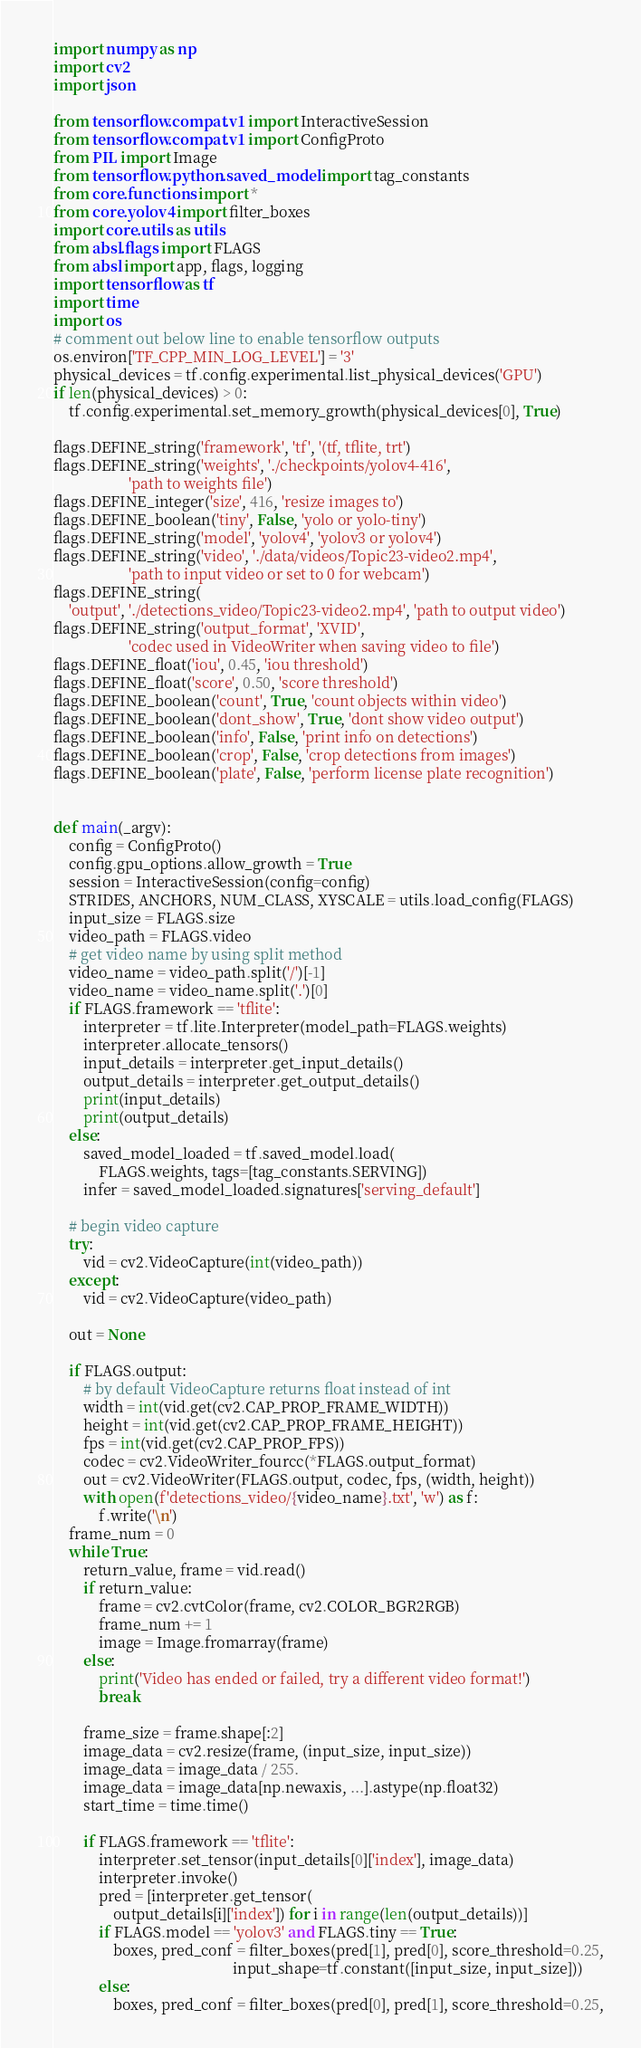<code> <loc_0><loc_0><loc_500><loc_500><_Python_>import numpy as np
import cv2
import json

from tensorflow.compat.v1 import InteractiveSession
from tensorflow.compat.v1 import ConfigProto
from PIL import Image
from tensorflow.python.saved_model import tag_constants
from core.functions import *
from core.yolov4 import filter_boxes
import core.utils as utils
from absl.flags import FLAGS
from absl import app, flags, logging
import tensorflow as tf
import time
import os
# comment out below line to enable tensorflow outputs
os.environ['TF_CPP_MIN_LOG_LEVEL'] = '3'
physical_devices = tf.config.experimental.list_physical_devices('GPU')
if len(physical_devices) > 0:
    tf.config.experimental.set_memory_growth(physical_devices[0], True)

flags.DEFINE_string('framework', 'tf', '(tf, tflite, trt')
flags.DEFINE_string('weights', './checkpoints/yolov4-416',
                    'path to weights file')
flags.DEFINE_integer('size', 416, 'resize images to')
flags.DEFINE_boolean('tiny', False, 'yolo or yolo-tiny')
flags.DEFINE_string('model', 'yolov4', 'yolov3 or yolov4')
flags.DEFINE_string('video', './data/videos/Topic23-video2.mp4',
                    'path to input video or set to 0 for webcam')
flags.DEFINE_string(
    'output', './detections_video/Topic23-video2.mp4', 'path to output video')
flags.DEFINE_string('output_format', 'XVID',
                    'codec used in VideoWriter when saving video to file')
flags.DEFINE_float('iou', 0.45, 'iou threshold')
flags.DEFINE_float('score', 0.50, 'score threshold')
flags.DEFINE_boolean('count', True, 'count objects within video')
flags.DEFINE_boolean('dont_show', True, 'dont show video output')
flags.DEFINE_boolean('info', False, 'print info on detections')
flags.DEFINE_boolean('crop', False, 'crop detections from images')
flags.DEFINE_boolean('plate', False, 'perform license plate recognition')


def main(_argv):
    config = ConfigProto()
    config.gpu_options.allow_growth = True
    session = InteractiveSession(config=config)
    STRIDES, ANCHORS, NUM_CLASS, XYSCALE = utils.load_config(FLAGS)
    input_size = FLAGS.size
    video_path = FLAGS.video
    # get video name by using split method
    video_name = video_path.split('/')[-1]
    video_name = video_name.split('.')[0]
    if FLAGS.framework == 'tflite':
        interpreter = tf.lite.Interpreter(model_path=FLAGS.weights)
        interpreter.allocate_tensors()
        input_details = interpreter.get_input_details()
        output_details = interpreter.get_output_details()
        print(input_details)
        print(output_details)
    else:
        saved_model_loaded = tf.saved_model.load(
            FLAGS.weights, tags=[tag_constants.SERVING])
        infer = saved_model_loaded.signatures['serving_default']

    # begin video capture
    try:
        vid = cv2.VideoCapture(int(video_path))
    except:
        vid = cv2.VideoCapture(video_path)

    out = None

    if FLAGS.output:
        # by default VideoCapture returns float instead of int
        width = int(vid.get(cv2.CAP_PROP_FRAME_WIDTH))
        height = int(vid.get(cv2.CAP_PROP_FRAME_HEIGHT))
        fps = int(vid.get(cv2.CAP_PROP_FPS))
        codec = cv2.VideoWriter_fourcc(*FLAGS.output_format)
        out = cv2.VideoWriter(FLAGS.output, codec, fps, (width, height))
        with open(f'detections_video/{video_name}.txt', 'w') as f:
            f.write('\n')
    frame_num = 0
    while True:
        return_value, frame = vid.read()
        if return_value:
            frame = cv2.cvtColor(frame, cv2.COLOR_BGR2RGB)
            frame_num += 1
            image = Image.fromarray(frame)
        else:
            print('Video has ended or failed, try a different video format!')
            break

        frame_size = frame.shape[:2]
        image_data = cv2.resize(frame, (input_size, input_size))
        image_data = image_data / 255.
        image_data = image_data[np.newaxis, ...].astype(np.float32)
        start_time = time.time()

        if FLAGS.framework == 'tflite':
            interpreter.set_tensor(input_details[0]['index'], image_data)
            interpreter.invoke()
            pred = [interpreter.get_tensor(
                output_details[i]['index']) for i in range(len(output_details))]
            if FLAGS.model == 'yolov3' and FLAGS.tiny == True:
                boxes, pred_conf = filter_boxes(pred[1], pred[0], score_threshold=0.25,
                                                input_shape=tf.constant([input_size, input_size]))
            else:
                boxes, pred_conf = filter_boxes(pred[0], pred[1], score_threshold=0.25,</code> 